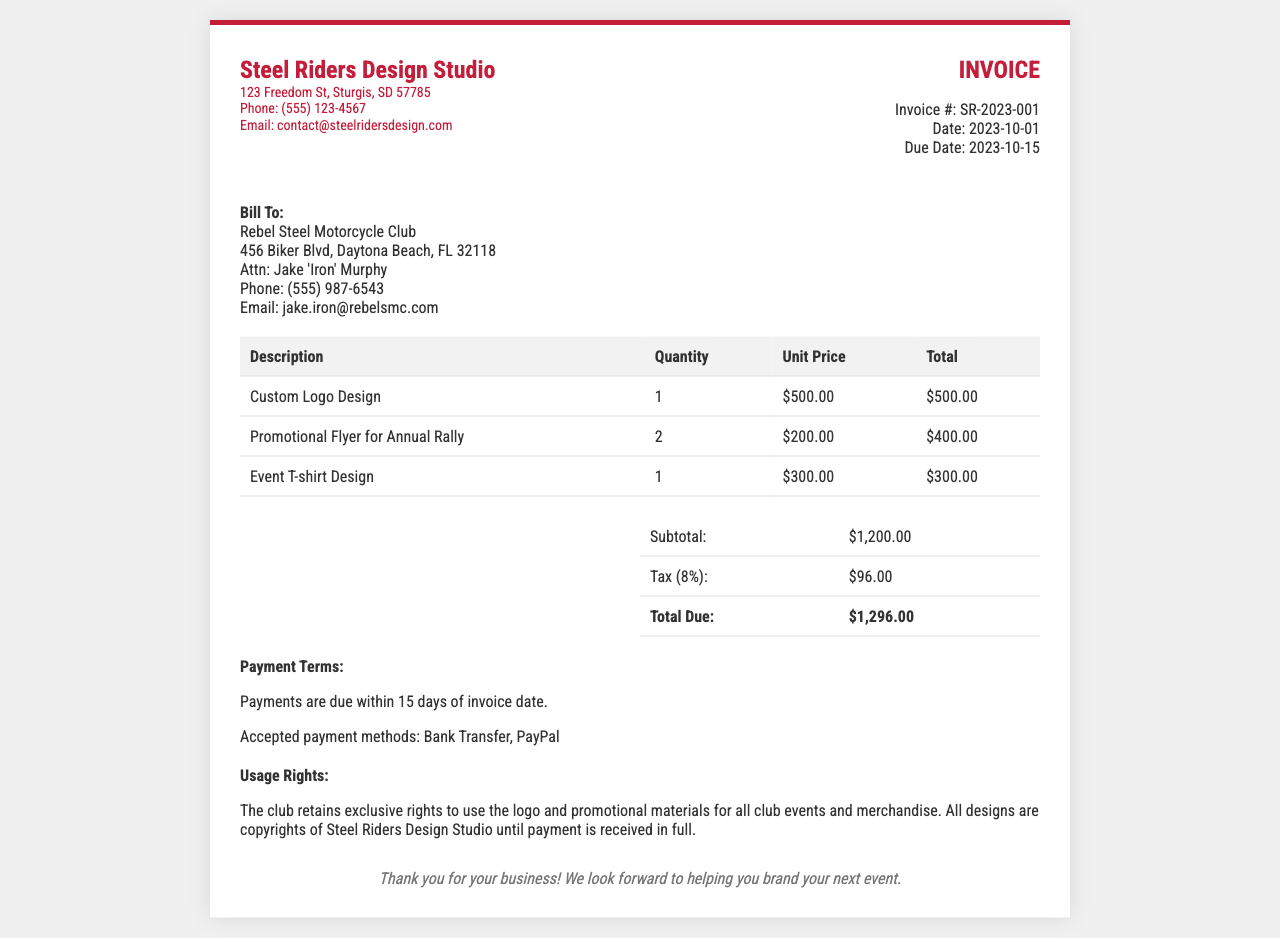What is the invoice number? The invoice number is provided in the invoice details section, marked as Invoice #: SR-2023-001.
Answer: SR-2023-001 What is the date of the invoice? The date is specified in the invoice details section as Date: 2023-10-01.
Answer: 2023-10-01 Who is the client being billed? The billing information is detailed under "Bill To", naming the client as Rebel Steel Motorcycle Club.
Answer: Rebel Steel Motorcycle Club What is the subtotal amount before tax? The subtotal is indicated in the summary table as Subtotal: $1,200.00.
Answer: $1,200.00 What is the tax rate applied to the invoice? The tax is calculated at a rate of 8%, which is mentioned in the summary table: Tax (8%).
Answer: 8% What payment methods are accepted? The accepted payment methods are listed in the payment terms section as Bank Transfer, PayPal.
Answer: Bank Transfer, PayPal What are the usage rights for the designs? The usage rights state that the club retains exclusive rights to use the logo and materials, and designs remain the copyright of Steel Riders Design Studio until payment is made.
Answer: Exclusive rights for club use; copyrights with Steel Riders until payment When is the payment due? The due date is outlined in the invoice details section as Due Date: 2023-10-15.
Answer: 2023-10-15 How many promotional flyers are included in the invoice? The quantity for promotional flyers is detailed in the table, showing 2 for the entry "Promotional Flyer for Annual Rally."
Answer: 2 